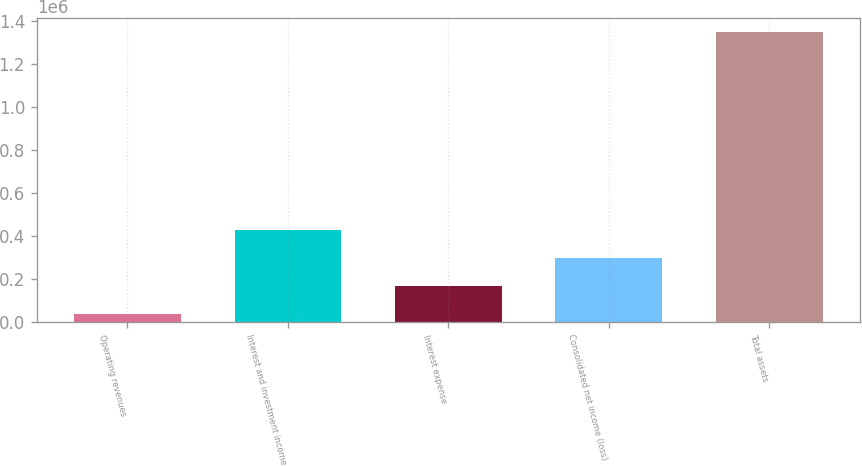Convert chart. <chart><loc_0><loc_0><loc_500><loc_500><bar_chart><fcel>Operating revenues<fcel>Interest and investment income<fcel>Interest expense<fcel>Consolidated net income (loss)<fcel>Total assets<nl><fcel>33369<fcel>428055<fcel>164931<fcel>296493<fcel>1.34899e+06<nl></chart> 